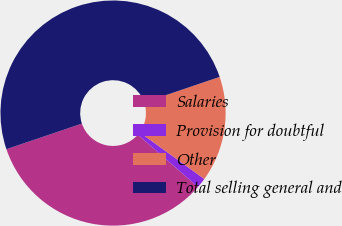Convert chart to OTSL. <chart><loc_0><loc_0><loc_500><loc_500><pie_chart><fcel>Salaries<fcel>Provision for doubtful<fcel>Other<fcel>Total selling general and<nl><fcel>33.4%<fcel>1.45%<fcel>15.16%<fcel>50.0%<nl></chart> 